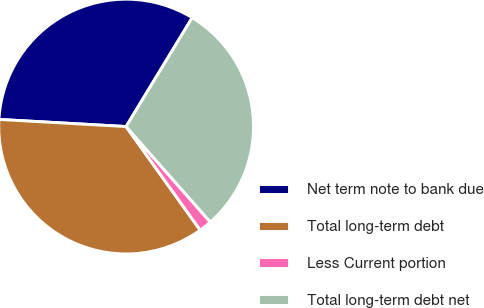Convert chart. <chart><loc_0><loc_0><loc_500><loc_500><pie_chart><fcel>Net term note to bank due<fcel>Total long-term debt<fcel>Less Current portion<fcel>Total long-term debt net<nl><fcel>32.79%<fcel>35.77%<fcel>1.62%<fcel>29.81%<nl></chart> 